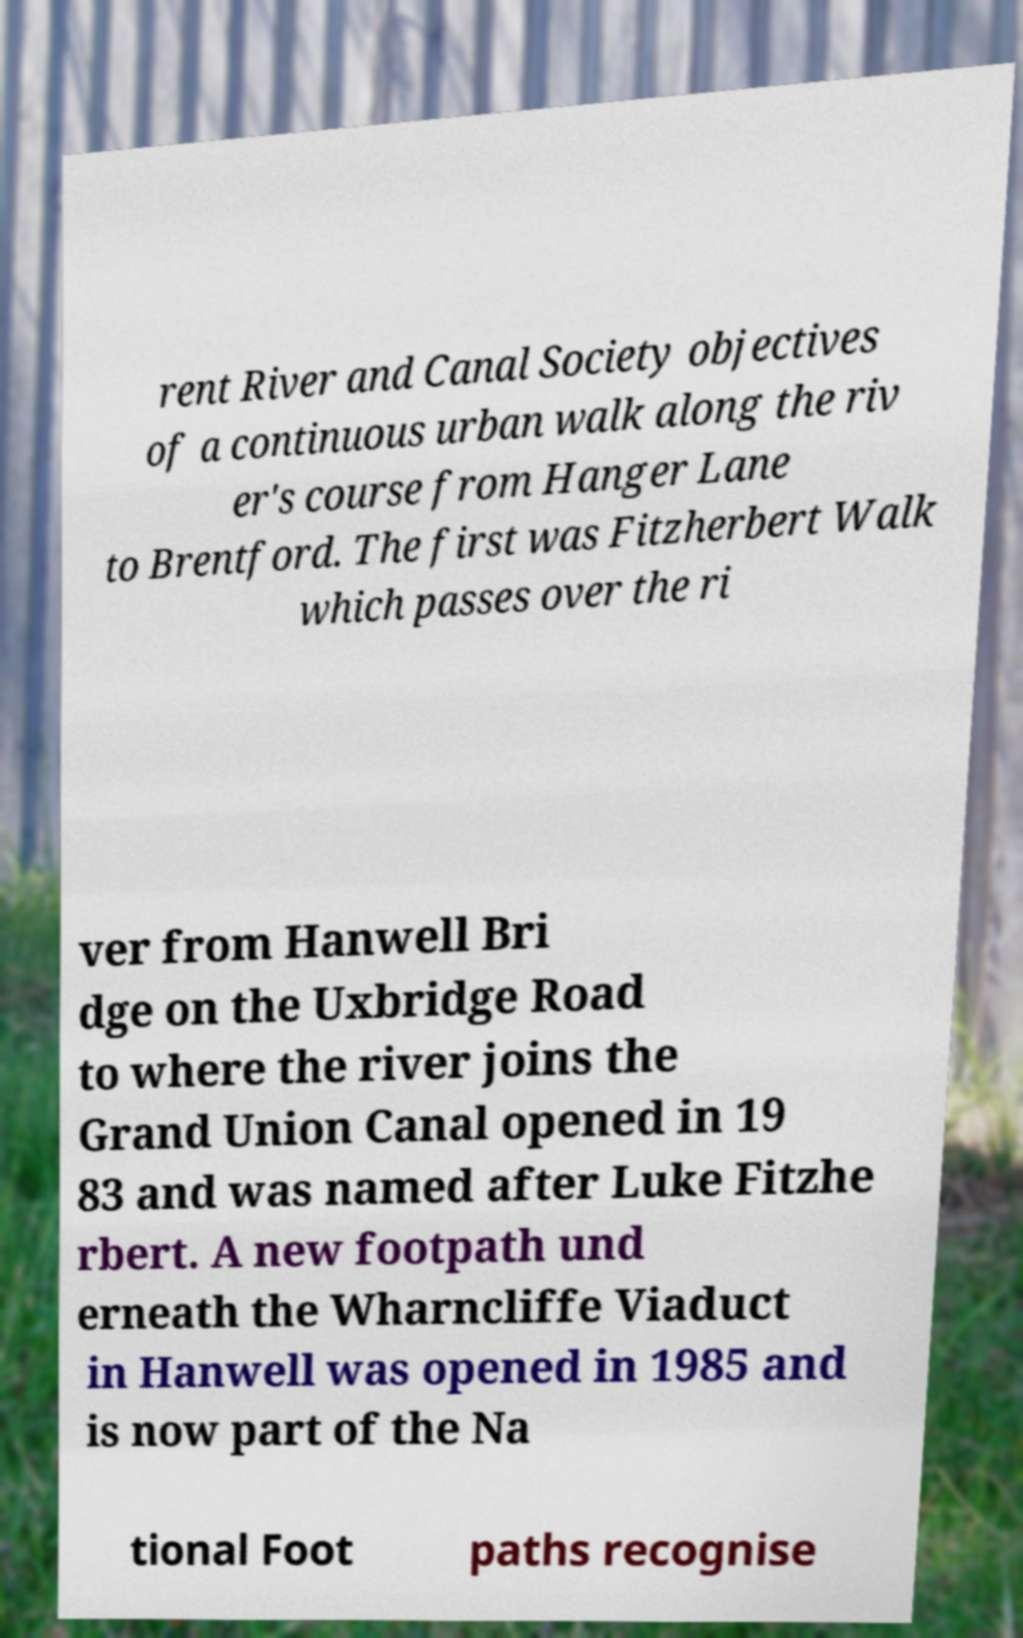Could you assist in decoding the text presented in this image and type it out clearly? rent River and Canal Society objectives of a continuous urban walk along the riv er's course from Hanger Lane to Brentford. The first was Fitzherbert Walk which passes over the ri ver from Hanwell Bri dge on the Uxbridge Road to where the river joins the Grand Union Canal opened in 19 83 and was named after Luke Fitzhe rbert. A new footpath und erneath the Wharncliffe Viaduct in Hanwell was opened in 1985 and is now part of the Na tional Foot paths recognise 